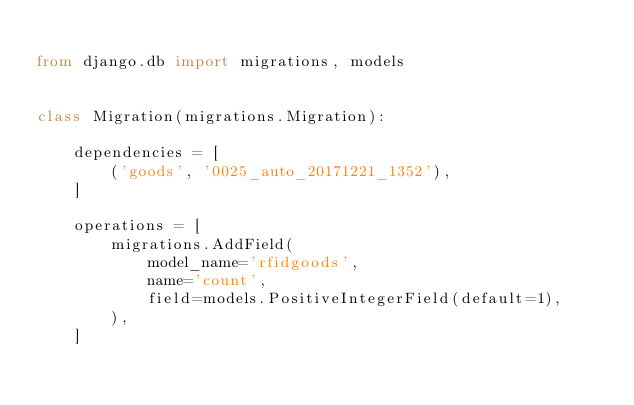Convert code to text. <code><loc_0><loc_0><loc_500><loc_500><_Python_>
from django.db import migrations, models


class Migration(migrations.Migration):

    dependencies = [
        ('goods', '0025_auto_20171221_1352'),
    ]

    operations = [
        migrations.AddField(
            model_name='rfidgoods',
            name='count',
            field=models.PositiveIntegerField(default=1),
        ),
    ]
</code> 